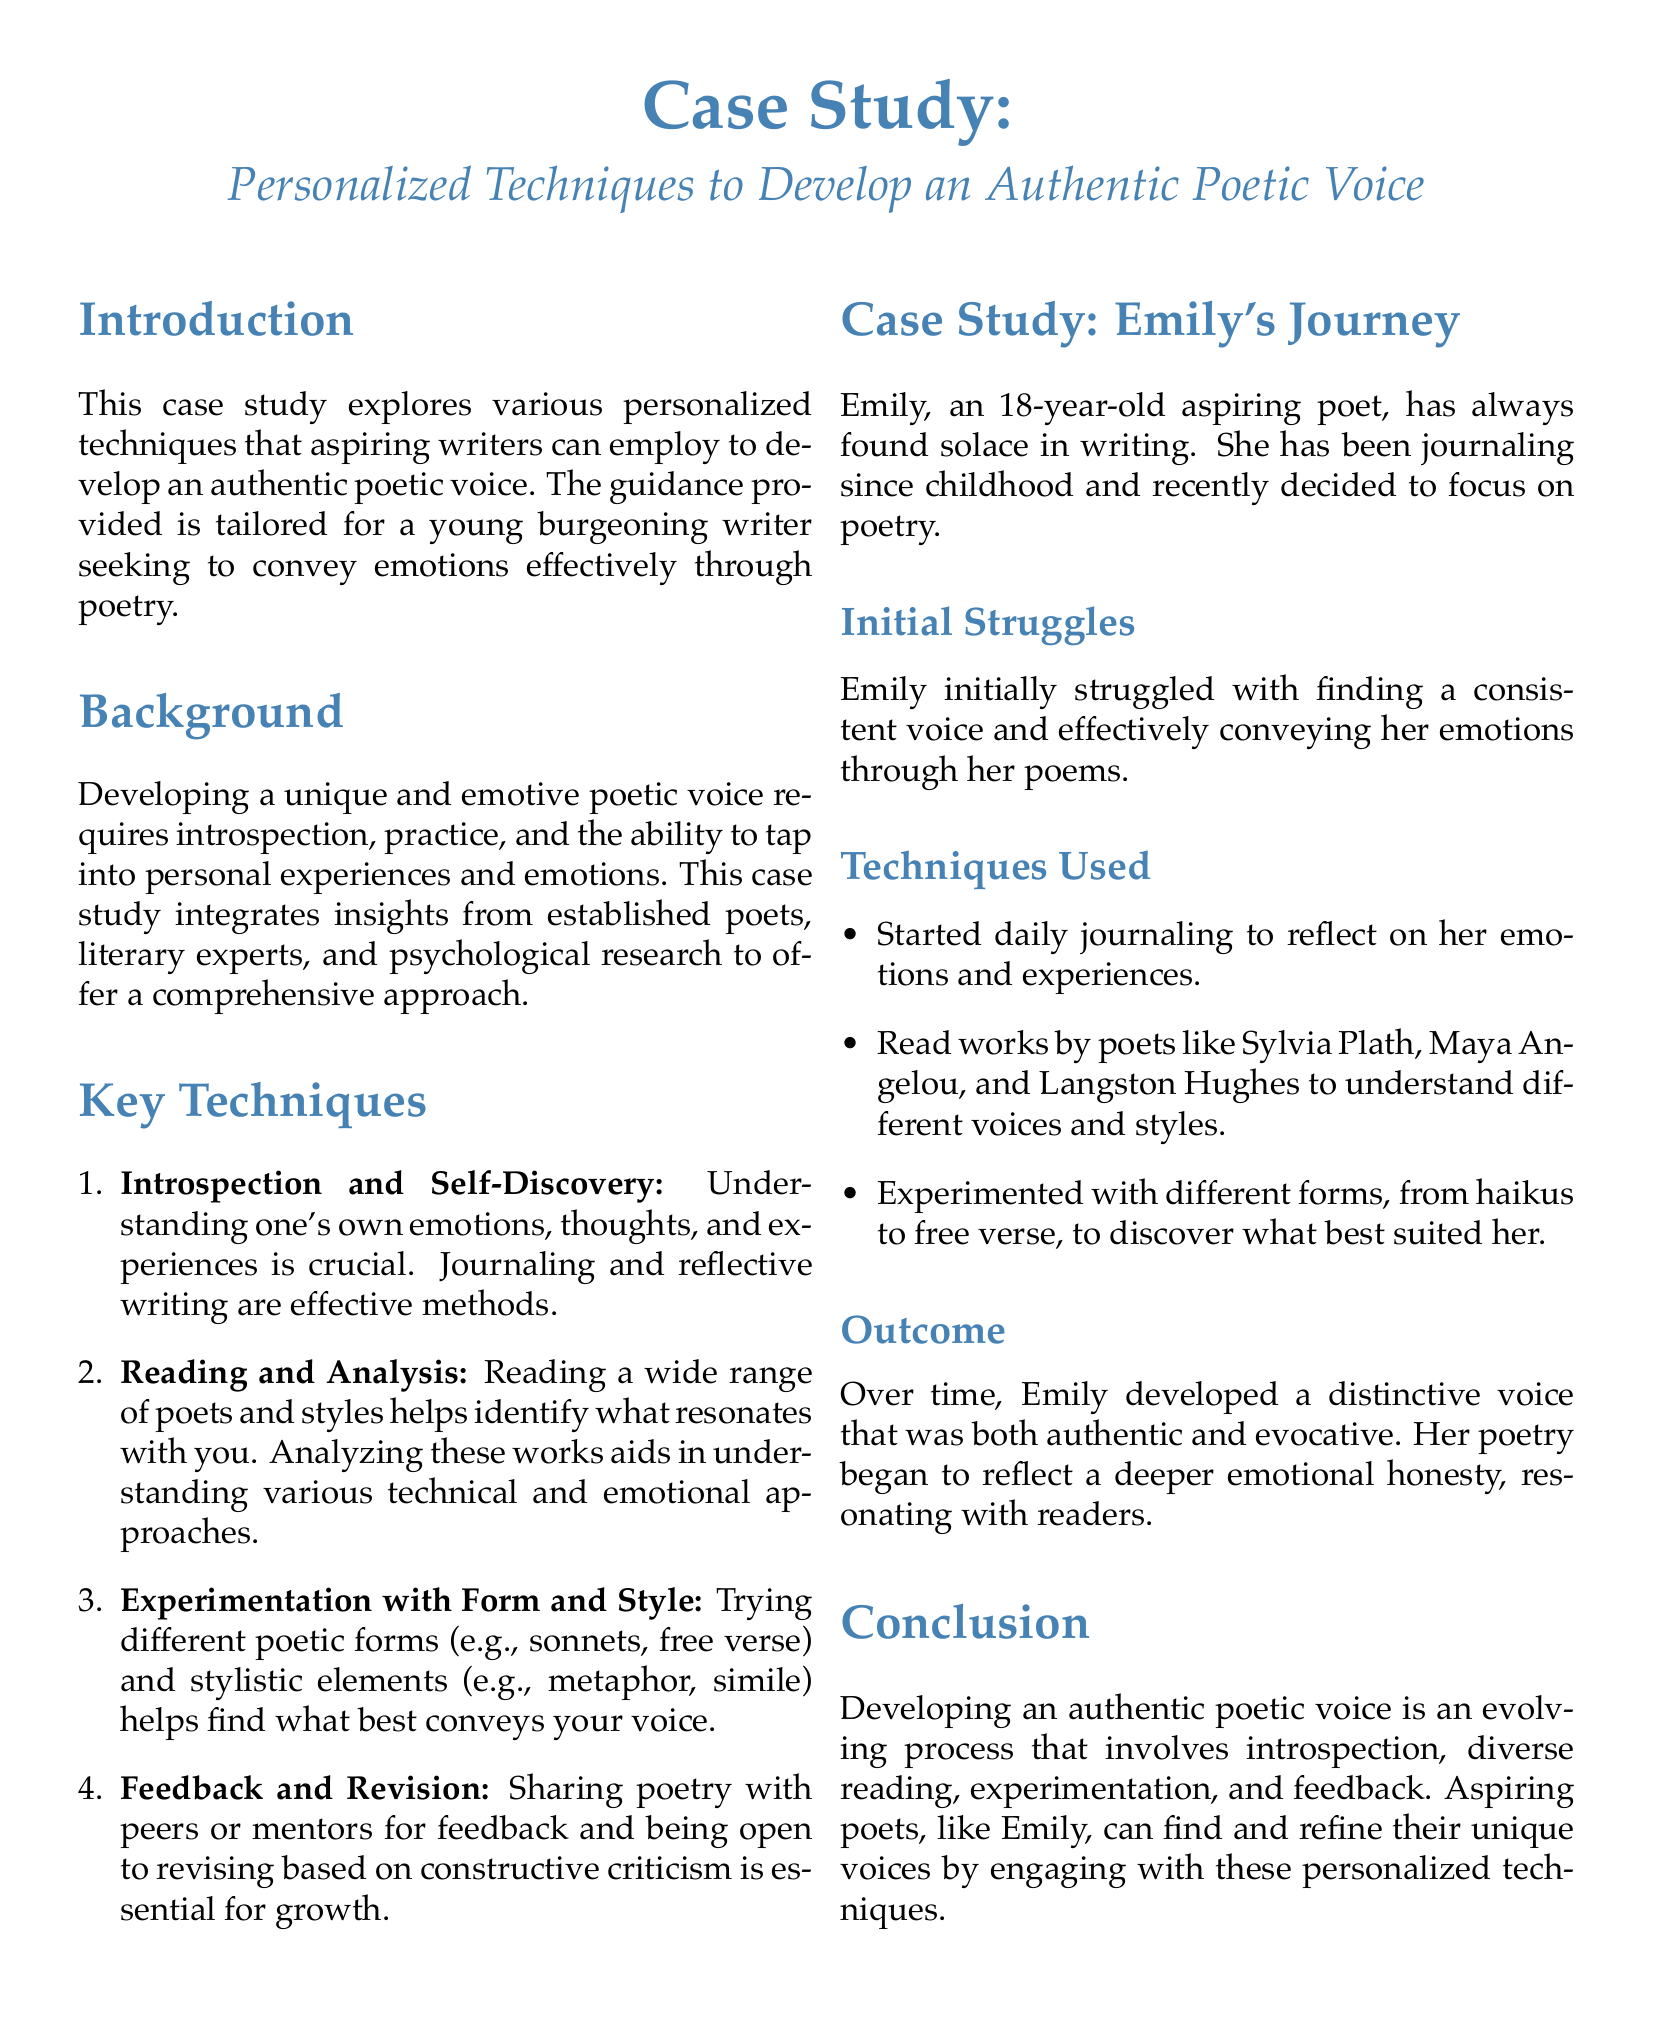What is the title of the case study? The title of the case study is explicitly mentioned at the beginning of the document.
Answer: Personalized Techniques to Develop an Authentic Poetic Voice Who is the subject of the case study? The subject of the case study is introduced in a specific section detailing her journey as a poet.
Answer: Emily What age is Emily in the case study? Emily's age is stated clearly in her introduction within the case study.
Answer: 18 Which technique involves sharing poetry for feedback? This technique is listed as crucial for growth in the key techniques section.
Answer: Feedback and Revision What method did Emily use to reflect on her emotions? The document specifies a practice she adopted to enhance her understanding of emotions.
Answer: Daily journaling How did Emily explore different voices and styles? The document highlights a literary practice used by Emily to accomplish this exploration.
Answer: Reading works by poets What was the outcome of Emily's journey? The conclusion of Emily's experience is summarized in a single phrase describing her voice.
Answer: A distinctive voice that was both authentic and evocative What are the key areas emphasized for developing a poetic voice? The document presents specific areas in the key techniques section focused on developing this voice.
Answer: Introspection, reading, experimentation, feedback 